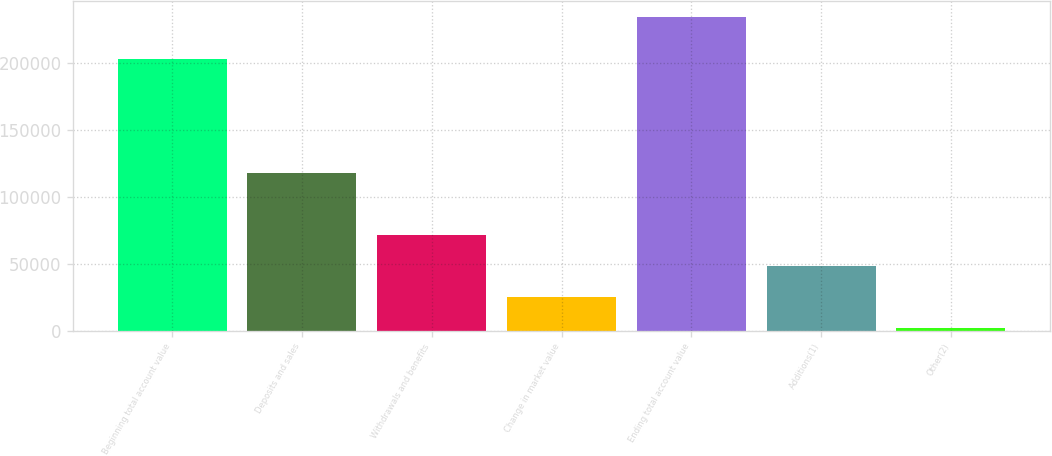Convert chart. <chart><loc_0><loc_0><loc_500><loc_500><bar_chart><fcel>Beginning total account value<fcel>Deposits and sales<fcel>Withdrawals and benefits<fcel>Change in market value<fcel>Ending total account value<fcel>Additions(1)<fcel>Other(2)<nl><fcel>202802<fcel>118159<fcel>71576.2<fcel>24993.4<fcel>234616<fcel>48284.8<fcel>1702<nl></chart> 